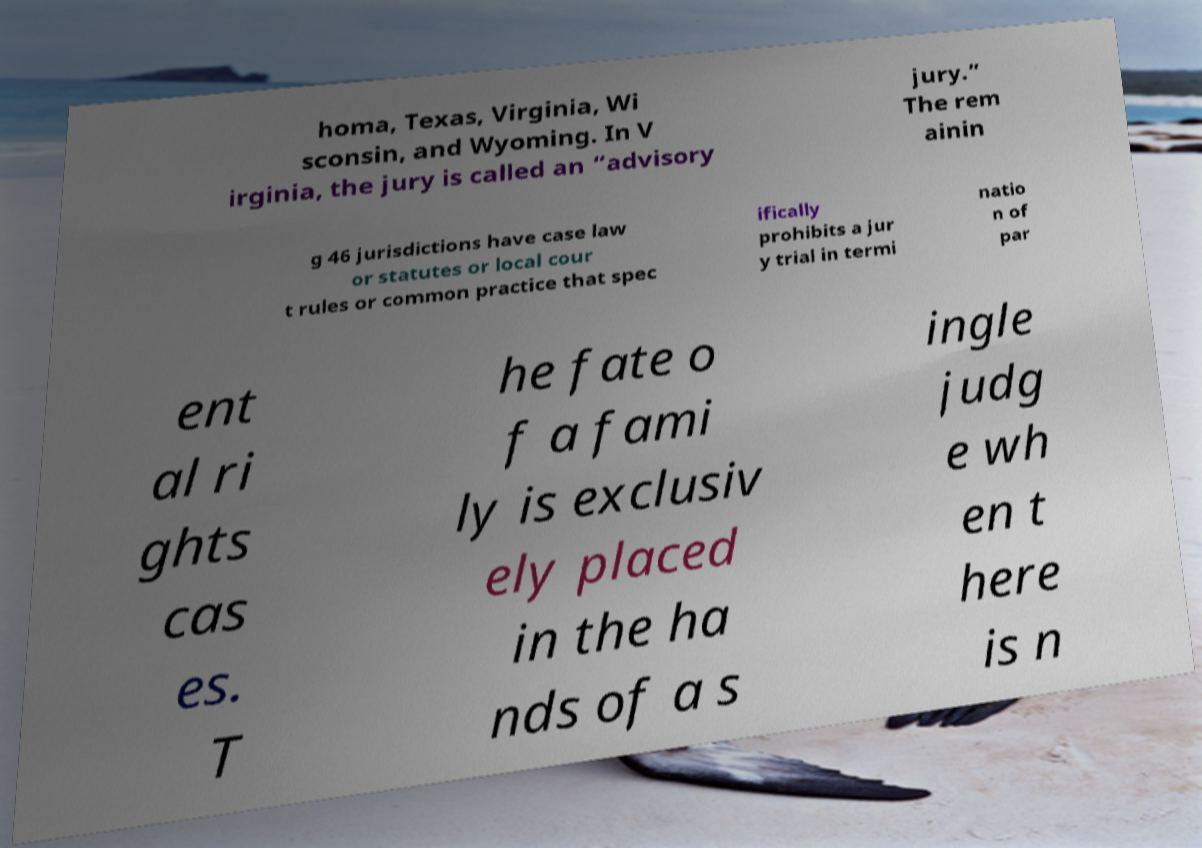For documentation purposes, I need the text within this image transcribed. Could you provide that? homa, Texas, Virginia, Wi sconsin, and Wyoming. In V irginia, the jury is called an “advisory jury.” The rem ainin g 46 jurisdictions have case law or statutes or local cour t rules or common practice that spec ifically prohibits a jur y trial in termi natio n of par ent al ri ghts cas es. T he fate o f a fami ly is exclusiv ely placed in the ha nds of a s ingle judg e wh en t here is n 